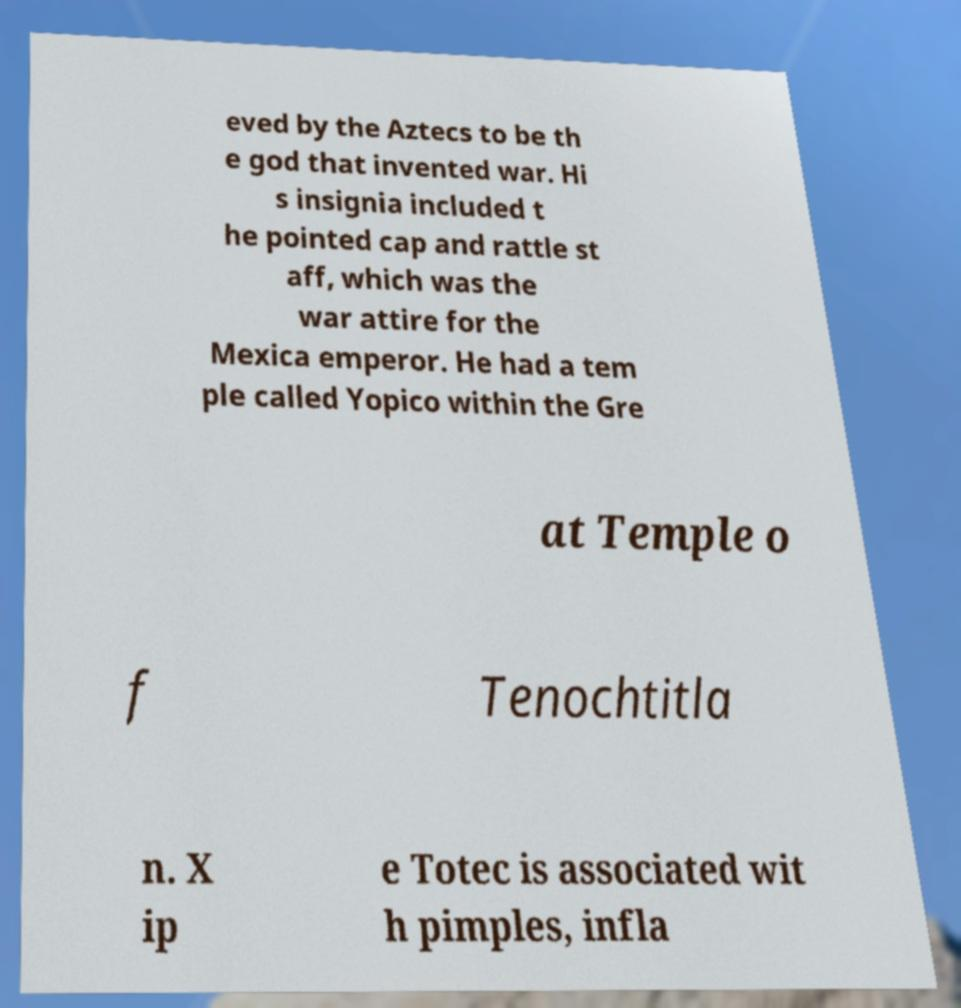Could you extract and type out the text from this image? eved by the Aztecs to be th e god that invented war. Hi s insignia included t he pointed cap and rattle st aff, which was the war attire for the Mexica emperor. He had a tem ple called Yopico within the Gre at Temple o f Tenochtitla n. X ip e Totec is associated wit h pimples, infla 